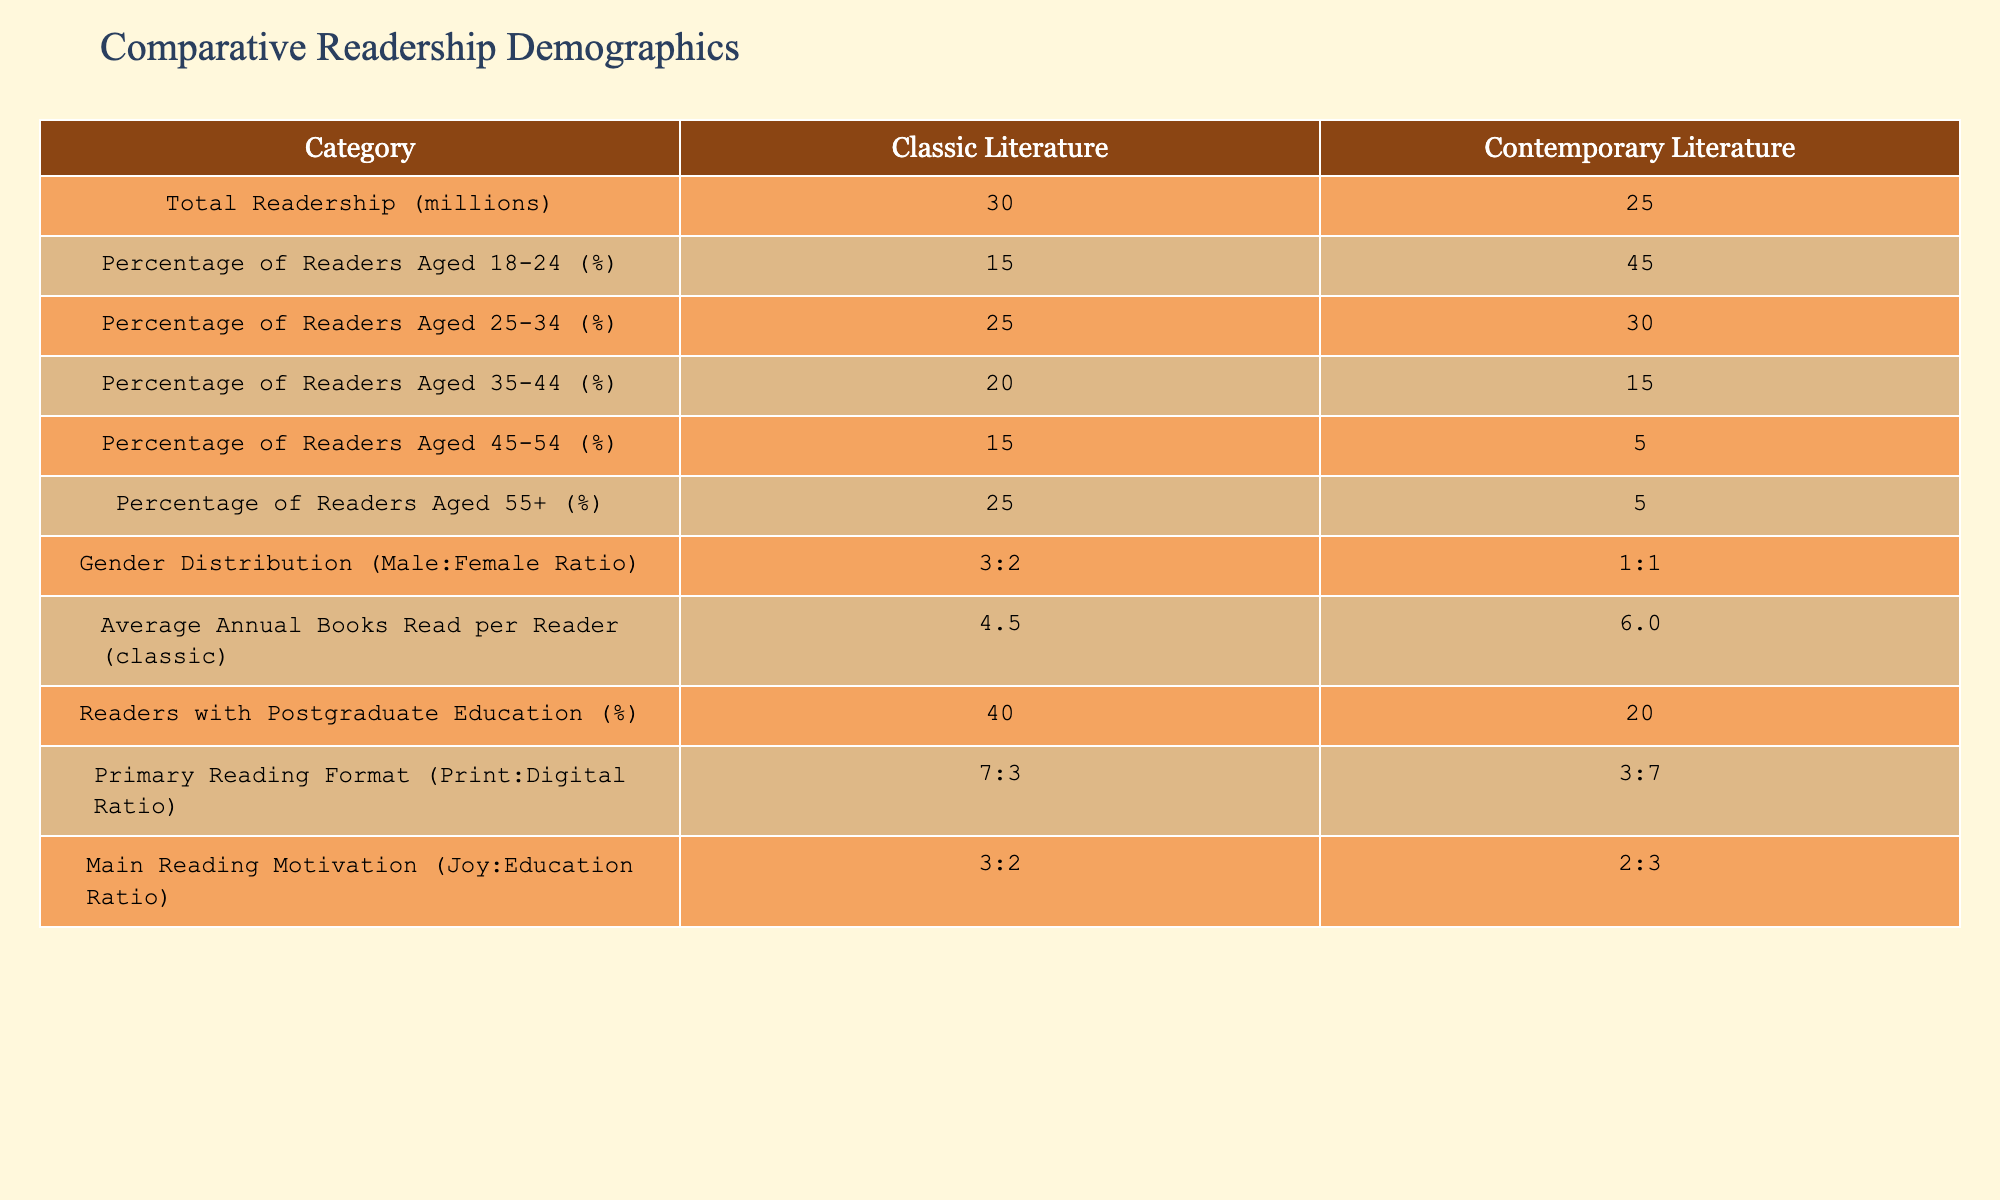What is the total readership for classic literature? The table indicates that the total readership for classic literature is specified under the "Total Readership (millions)" row. The value given is 30 million.
Answer: 30 million What percentage of readers aged 18-24 read contemporary literature? The table shows the percentage of readers aged 18-24 who prefer contemporary literature under the respective column. It is 45%.
Answer: 45% Is the average number of books read by classic literature readers higher than that of contemporary literature readers? By comparing the figures provided in the table, the average number of books read per classic literature reader is 4.5, while for contemporary literature readers it is 6.0. Since 4.5 is less than 6.0, the answer is no.
Answer: No What is the ratio of male to female readers for classic literature? The table lists the gender distribution for classic literature with a ratio of 3:2. This means for every five readers, three are male and two are female.
Answer: 3:2 What is the combined percentage of readers aged 45 and older for both types of literature? To find this, we need to add the percentages of two age groups: for classic literature, the percentage of readers aged 45-54 is 15% and aged 55+ is 25%, totaling 40%. For contemporary literature, the percentage for both groups adds up to 5% (for 45-54) + 5% (for 55+), which is 10%. Combining both totals gives us 40% + 10% = 50%.
Answer: 50% Does a higher percentage of postgraduate-educated readers prefer classic literature compared to contemporary literature? The table shows that 40% of readers of classic literature have postgraduate education, whereas only 20% of contemporary literature readers have the same level of education. Since 40% is greater than 20%, the answer is yes.
Answer: Yes What is the average ratio of joy to education as reading motivation for classic literature? The main reading motivation for classic literature is presented in the table as a ratio of joy to education of 3:2. This ratio indicates that for every five readers, three read for joy and two for education.
Answer: 3:2 If we consider only readers aged 35 and older, what is the percentage of these readers for contemporary literature? The table indicates that readers aged 35-44 for contemporary literature make up 15%, and those aged 55+ are at 5%. However, for contemporary literature, readers aged 45-54 hold a percentage of 5%. Adding the relevant age categories together gives us 15% + 5% + 5% = 25%.
Answer: 25% What is the percentage of contemporary literature readers who prefer digital formats? In the table, the primary reading format for contemporary literature has a ratio of 3:7 (Print:Digital). To find the percentage of digital readers, we calculate: 7 out of a total of 10 parts (3+7), equals 70%.
Answer: 70% 